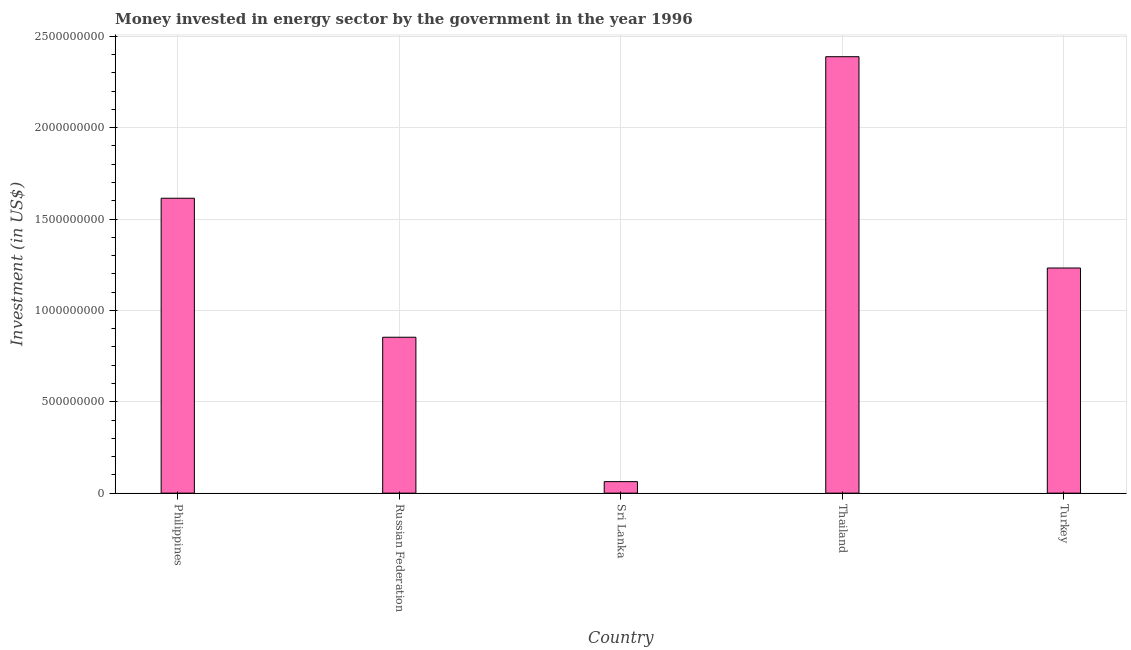Does the graph contain any zero values?
Your response must be concise. No. Does the graph contain grids?
Offer a very short reply. Yes. What is the title of the graph?
Provide a short and direct response. Money invested in energy sector by the government in the year 1996. What is the label or title of the X-axis?
Keep it short and to the point. Country. What is the label or title of the Y-axis?
Offer a very short reply. Investment (in US$). What is the investment in energy in Sri Lanka?
Give a very brief answer. 6.30e+07. Across all countries, what is the maximum investment in energy?
Provide a short and direct response. 2.39e+09. Across all countries, what is the minimum investment in energy?
Offer a terse response. 6.30e+07. In which country was the investment in energy maximum?
Your response must be concise. Thailand. In which country was the investment in energy minimum?
Offer a very short reply. Sri Lanka. What is the sum of the investment in energy?
Offer a terse response. 6.15e+09. What is the difference between the investment in energy in Philippines and Russian Federation?
Offer a terse response. 7.61e+08. What is the average investment in energy per country?
Your response must be concise. 1.23e+09. What is the median investment in energy?
Provide a succinct answer. 1.23e+09. What is the ratio of the investment in energy in Russian Federation to that in Thailand?
Offer a terse response. 0.36. Is the investment in energy in Russian Federation less than that in Turkey?
Keep it short and to the point. Yes. What is the difference between the highest and the second highest investment in energy?
Provide a short and direct response. 7.75e+08. Is the sum of the investment in energy in Philippines and Russian Federation greater than the maximum investment in energy across all countries?
Make the answer very short. Yes. What is the difference between the highest and the lowest investment in energy?
Your answer should be compact. 2.33e+09. In how many countries, is the investment in energy greater than the average investment in energy taken over all countries?
Keep it short and to the point. 3. Are all the bars in the graph horizontal?
Your answer should be compact. No. How many countries are there in the graph?
Offer a terse response. 5. What is the difference between two consecutive major ticks on the Y-axis?
Your response must be concise. 5.00e+08. Are the values on the major ticks of Y-axis written in scientific E-notation?
Make the answer very short. No. What is the Investment (in US$) in Philippines?
Your response must be concise. 1.61e+09. What is the Investment (in US$) of Russian Federation?
Your response must be concise. 8.53e+08. What is the Investment (in US$) in Sri Lanka?
Your answer should be very brief. 6.30e+07. What is the Investment (in US$) in Thailand?
Offer a very short reply. 2.39e+09. What is the Investment (in US$) in Turkey?
Provide a succinct answer. 1.23e+09. What is the difference between the Investment (in US$) in Philippines and Russian Federation?
Your response must be concise. 7.61e+08. What is the difference between the Investment (in US$) in Philippines and Sri Lanka?
Your response must be concise. 1.55e+09. What is the difference between the Investment (in US$) in Philippines and Thailand?
Your response must be concise. -7.75e+08. What is the difference between the Investment (in US$) in Philippines and Turkey?
Ensure brevity in your answer.  3.82e+08. What is the difference between the Investment (in US$) in Russian Federation and Sri Lanka?
Your answer should be compact. 7.90e+08. What is the difference between the Investment (in US$) in Russian Federation and Thailand?
Give a very brief answer. -1.54e+09. What is the difference between the Investment (in US$) in Russian Federation and Turkey?
Provide a short and direct response. -3.79e+08. What is the difference between the Investment (in US$) in Sri Lanka and Thailand?
Your answer should be compact. -2.33e+09. What is the difference between the Investment (in US$) in Sri Lanka and Turkey?
Your answer should be compact. -1.17e+09. What is the difference between the Investment (in US$) in Thailand and Turkey?
Offer a terse response. 1.16e+09. What is the ratio of the Investment (in US$) in Philippines to that in Russian Federation?
Your answer should be very brief. 1.89. What is the ratio of the Investment (in US$) in Philippines to that in Sri Lanka?
Your answer should be very brief. 25.62. What is the ratio of the Investment (in US$) in Philippines to that in Thailand?
Provide a succinct answer. 0.68. What is the ratio of the Investment (in US$) in Philippines to that in Turkey?
Ensure brevity in your answer.  1.31. What is the ratio of the Investment (in US$) in Russian Federation to that in Sri Lanka?
Your answer should be very brief. 13.54. What is the ratio of the Investment (in US$) in Russian Federation to that in Thailand?
Offer a very short reply. 0.36. What is the ratio of the Investment (in US$) in Russian Federation to that in Turkey?
Ensure brevity in your answer.  0.69. What is the ratio of the Investment (in US$) in Sri Lanka to that in Thailand?
Ensure brevity in your answer.  0.03. What is the ratio of the Investment (in US$) in Sri Lanka to that in Turkey?
Give a very brief answer. 0.05. What is the ratio of the Investment (in US$) in Thailand to that in Turkey?
Offer a terse response. 1.94. 